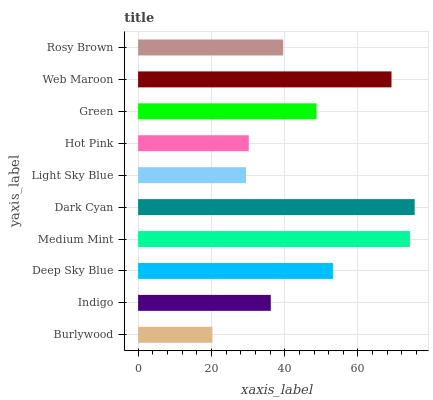Is Burlywood the minimum?
Answer yes or no. Yes. Is Dark Cyan the maximum?
Answer yes or no. Yes. Is Indigo the minimum?
Answer yes or no. No. Is Indigo the maximum?
Answer yes or no. No. Is Indigo greater than Burlywood?
Answer yes or no. Yes. Is Burlywood less than Indigo?
Answer yes or no. Yes. Is Burlywood greater than Indigo?
Answer yes or no. No. Is Indigo less than Burlywood?
Answer yes or no. No. Is Green the high median?
Answer yes or no. Yes. Is Rosy Brown the low median?
Answer yes or no. Yes. Is Web Maroon the high median?
Answer yes or no. No. Is Dark Cyan the low median?
Answer yes or no. No. 